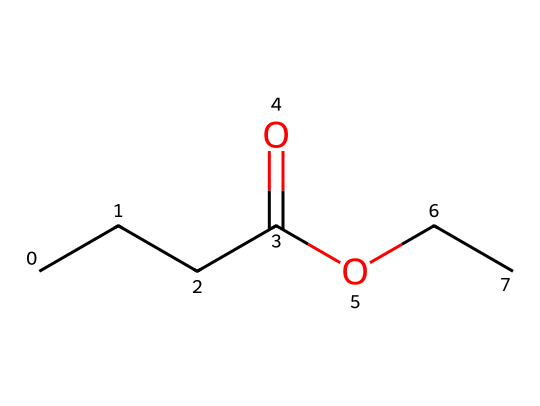what is the name of this chemical? The SMILES representation corresponds to the structure of ethyl butyrate, which is a well-known ester.
Answer: ethyl butyrate how many carbon atoms are present in this chemical? By analyzing the SMILES structure, we can count the carbon atoms. There are a total of five carbon atoms.
Answer: five how many hydrogen atoms does this chemical contain? Each carbon can form four bonds. Given the structure, we identify that there are 10 hydrogen atoms attached to the five carbon atoms in order to satisfy their valency.
Answer: ten what functional group is present in ethyl butyrate? The structure contains a carboxylate group (from the ester), indicated by the -OCC part connected to the carbonyl (C=O) part, which characterizes esters.
Answer: ester why does ethyl butyrate have a fruity flavor? The specific arrangement of atoms in ethyl butyrate, particularly the ester functional group, is known to produce fruity flavors, commonly found in fruits like pineapples and apples. The molecular structure is designed to evoke a fruity aroma due to the compounds it resembles in nature.
Answer: fruity flavors what is the role of the ester functional group in ethyl butyrate? The ester functional group (RCOOR') plays a key role in the flavor profile of ethyl butyrate. This group is responsible for the distinct fruity aroma and taste, which is linked to its volatile nature that can easily be perceived by the senses.
Answer: flavor profile how is ethyl butyrate typically used in beverages? Ethyl butyrate is commonly used as a flavoring agent in cocktails and mixers to enhance fruity and tropical notes, making it appealing in various drink recipes.
Answer: flavoring agent 